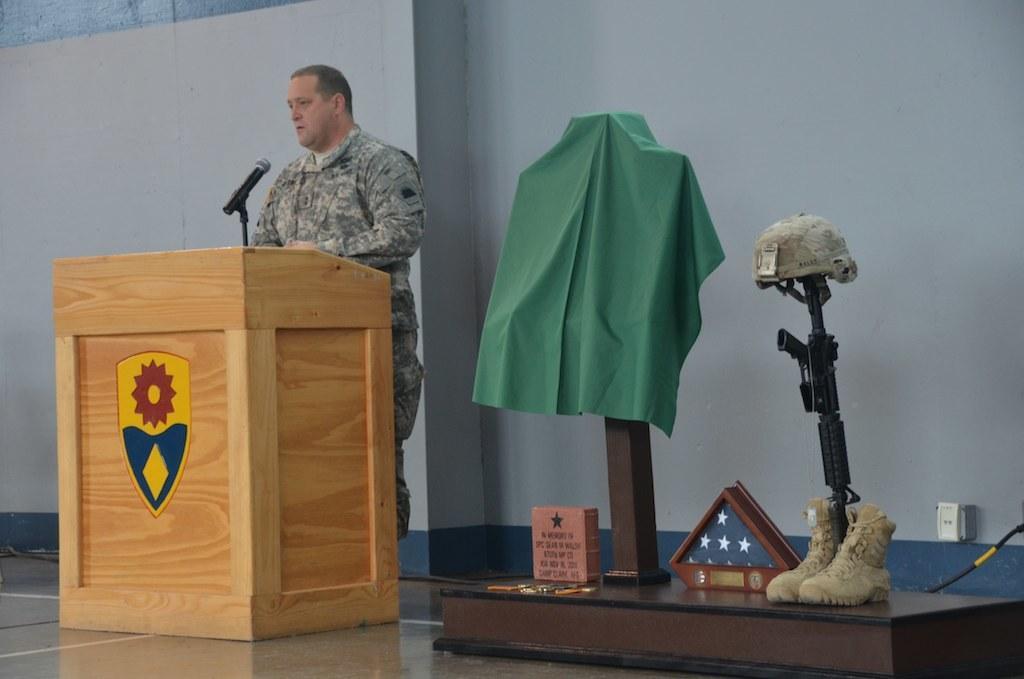In one or two sentences, can you explain what this image depicts? There is a man talking on the mike. This is a podium. Here we can see shoes, weapon, cap, and cloth. This is floor. In the background we can see wall. 